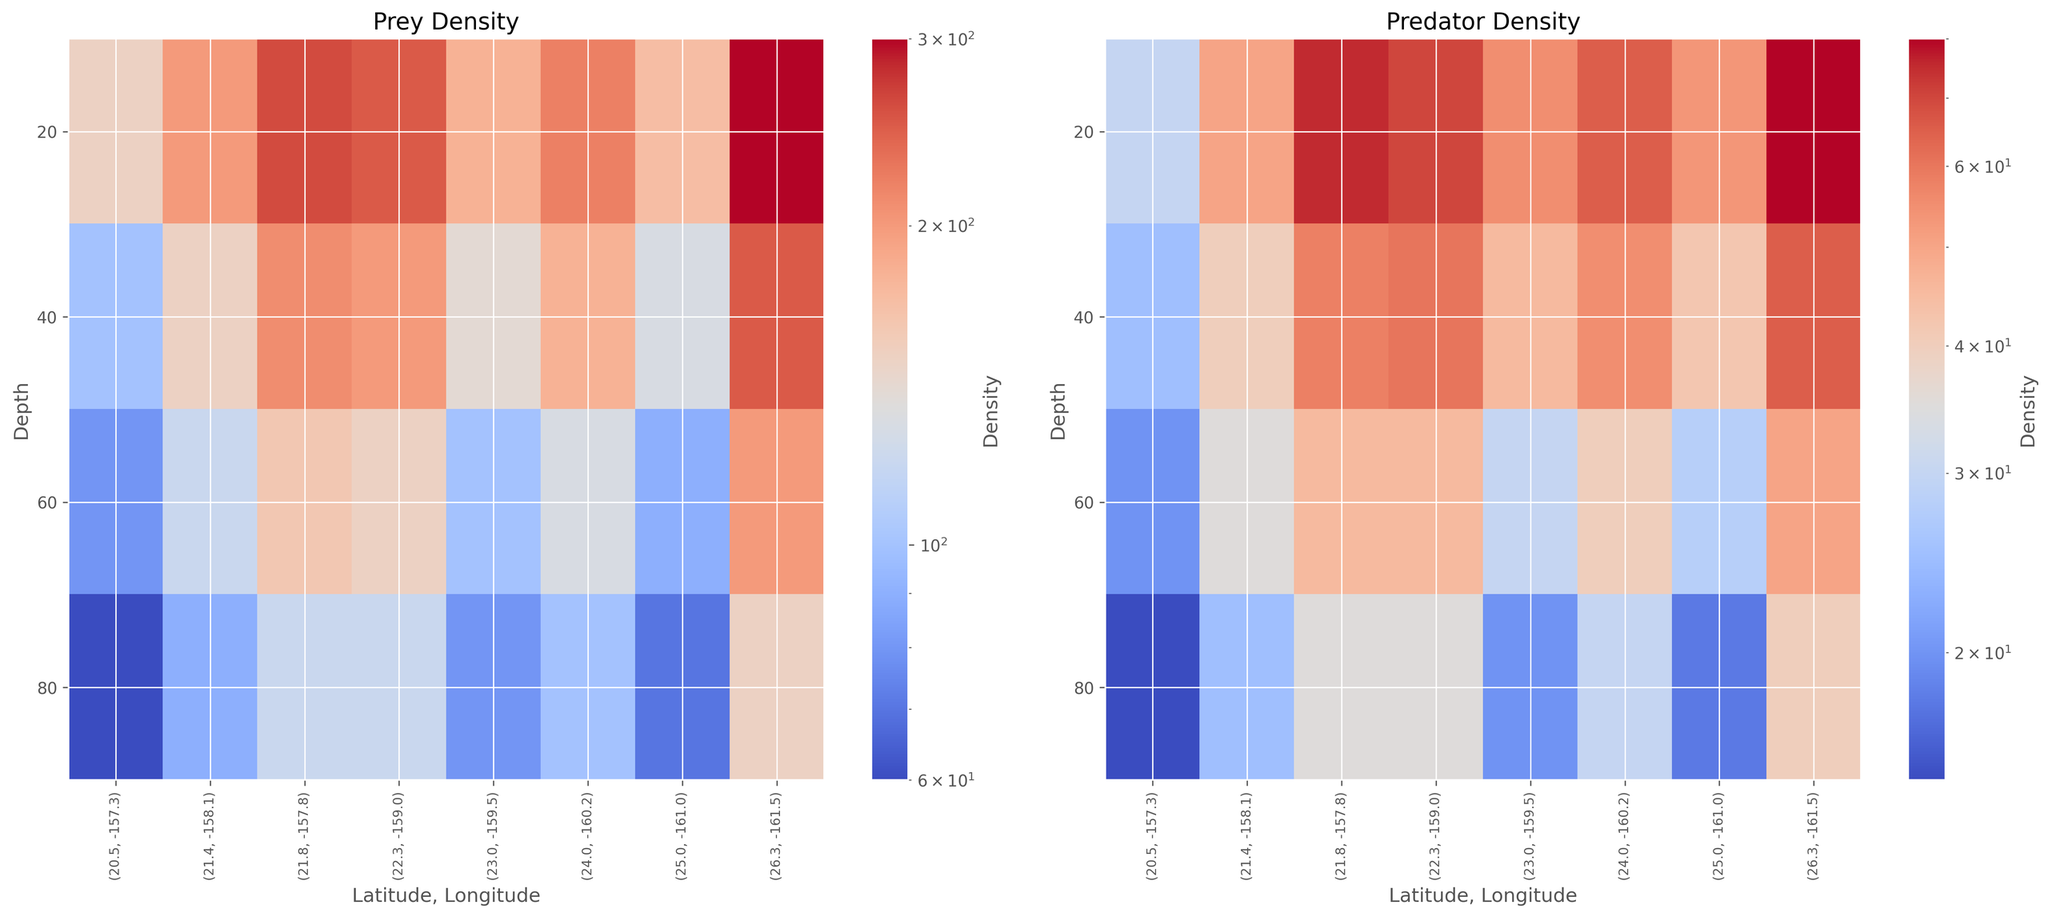What region has the highest prey density at a depth of 20 meters? To find this, look at the heatmap for Prey Density. Identify the column labeled with depth 20m and find the cell with the most intense color, which indicates the highest density.
Answer: 26.3, -161.5 How does predator density change with depth at latitude 22.3, longitude -159.0? Locate the column for latitude 22.3 and longitude -159.0 on the Predator Density heatmap, then read the color intensity from 20m to 80m depths. The color intensity decreases as depth increases, indicating lower predator density at greater depths.
Answer: decreases Comparing the prey density at depths 40m and 60m, which region shows the most significant density decrease? On the Prey Density heatmap, examine the colors for depths 40m and 60m across all regions. Find the region where the color difference between these two depths is the largest, indicating the most significant decrease in prey density.
Answer: 26.3, -161.5 What is the average prey density at a depth of 80 meters across all regions? Sum the prey densities for each region at the 80m depth, then divide by the number of regions. The values are 15, 25, 35, 20, 30, 18, 35, 40. Calculate the sum (15 + 25 + 35 + 20 + 30 + 18 + 35 + 40 = 218). There are 8 regions, so the average is 218/8 = 27.25
Answer: 27.25 Which region has the smallest difference between prey and predator densities at 60 meters? Subtract predator densities from prey densities at the 60m depth for each region and find the smallest absolute difference. The differences are (80-20=60), (120-35=85), (150-45=105), (100-30=70), (130-40=90), (90-28=62), (160-45=115), (200-50=150). The smallest difference is 60 at latitude 20.5, longitude -157.3.
Answer: 20.5, -157.3 Which region shows the highest increase in predator density from 20m to 40m? Compare predator densities at 20m and 40m for each region and find the largest difference. The differences are (25-30=-5), (40-50=-10), (60-70=-10), (45-55=-10), (55-65=-10), (42-53=-11), (58-75=-17), (65-80=-15). The largest increase is 5 at latitude 20.5, longitude -157.3.
Answer: 20.5, -157.3 What is the pattern of prey density across all depths at latitude 21.8, longitude -157.8? On the Prey Density heatmap, look at the column corresponding to latitude 21.8 and longitude -157.8, then observe the color intensity from top to bottom (20m to 80m). The pattern shows a high density at 20m that decreases gradually with increasing depth.
Answer: decreasing with depth Is there a depth where predator density exceeds prey density in any region? Look at the Predator Density and Prey Density heatmaps side by side. Compare cells across all depths and regions to see if any predator density is greater than the corresponding prey density. No predator density exceeds prey density in any region at any depth.
Answer: No What is the total predator density at 40 meters across all regions? Sum the predator densities at 40m depth for all regions. The values are 25, 40, 60, 45, 55, 42, 58, 65. Calculate the sum (25 + 40 + 60 + 45 + 55 + 42 + 58 + 65 = 390).
Answer: 390 